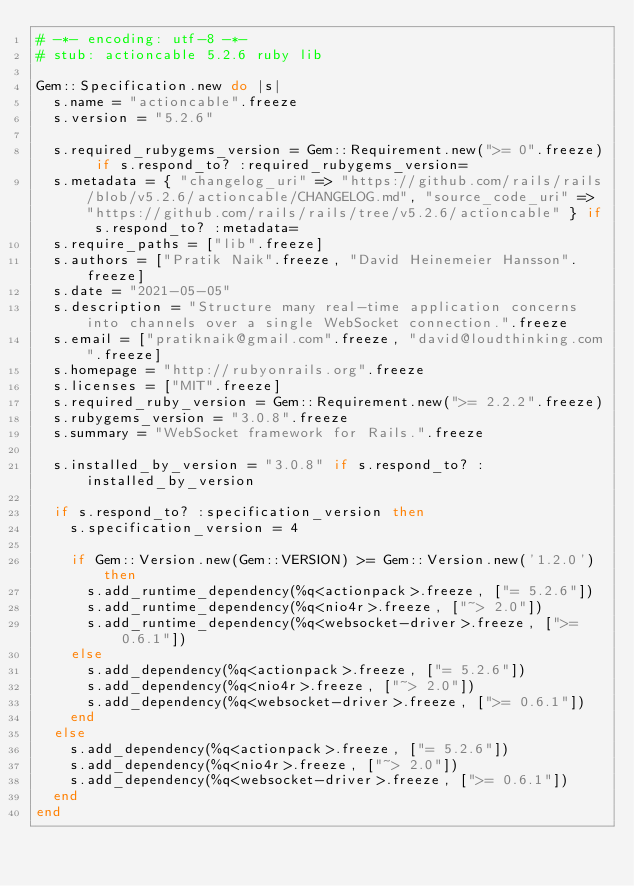Convert code to text. <code><loc_0><loc_0><loc_500><loc_500><_Ruby_># -*- encoding: utf-8 -*-
# stub: actioncable 5.2.6 ruby lib

Gem::Specification.new do |s|
  s.name = "actioncable".freeze
  s.version = "5.2.6"

  s.required_rubygems_version = Gem::Requirement.new(">= 0".freeze) if s.respond_to? :required_rubygems_version=
  s.metadata = { "changelog_uri" => "https://github.com/rails/rails/blob/v5.2.6/actioncable/CHANGELOG.md", "source_code_uri" => "https://github.com/rails/rails/tree/v5.2.6/actioncable" } if s.respond_to? :metadata=
  s.require_paths = ["lib".freeze]
  s.authors = ["Pratik Naik".freeze, "David Heinemeier Hansson".freeze]
  s.date = "2021-05-05"
  s.description = "Structure many real-time application concerns into channels over a single WebSocket connection.".freeze
  s.email = ["pratiknaik@gmail.com".freeze, "david@loudthinking.com".freeze]
  s.homepage = "http://rubyonrails.org".freeze
  s.licenses = ["MIT".freeze]
  s.required_ruby_version = Gem::Requirement.new(">= 2.2.2".freeze)
  s.rubygems_version = "3.0.8".freeze
  s.summary = "WebSocket framework for Rails.".freeze

  s.installed_by_version = "3.0.8" if s.respond_to? :installed_by_version

  if s.respond_to? :specification_version then
    s.specification_version = 4

    if Gem::Version.new(Gem::VERSION) >= Gem::Version.new('1.2.0') then
      s.add_runtime_dependency(%q<actionpack>.freeze, ["= 5.2.6"])
      s.add_runtime_dependency(%q<nio4r>.freeze, ["~> 2.0"])
      s.add_runtime_dependency(%q<websocket-driver>.freeze, [">= 0.6.1"])
    else
      s.add_dependency(%q<actionpack>.freeze, ["= 5.2.6"])
      s.add_dependency(%q<nio4r>.freeze, ["~> 2.0"])
      s.add_dependency(%q<websocket-driver>.freeze, [">= 0.6.1"])
    end
  else
    s.add_dependency(%q<actionpack>.freeze, ["= 5.2.6"])
    s.add_dependency(%q<nio4r>.freeze, ["~> 2.0"])
    s.add_dependency(%q<websocket-driver>.freeze, [">= 0.6.1"])
  end
end
</code> 